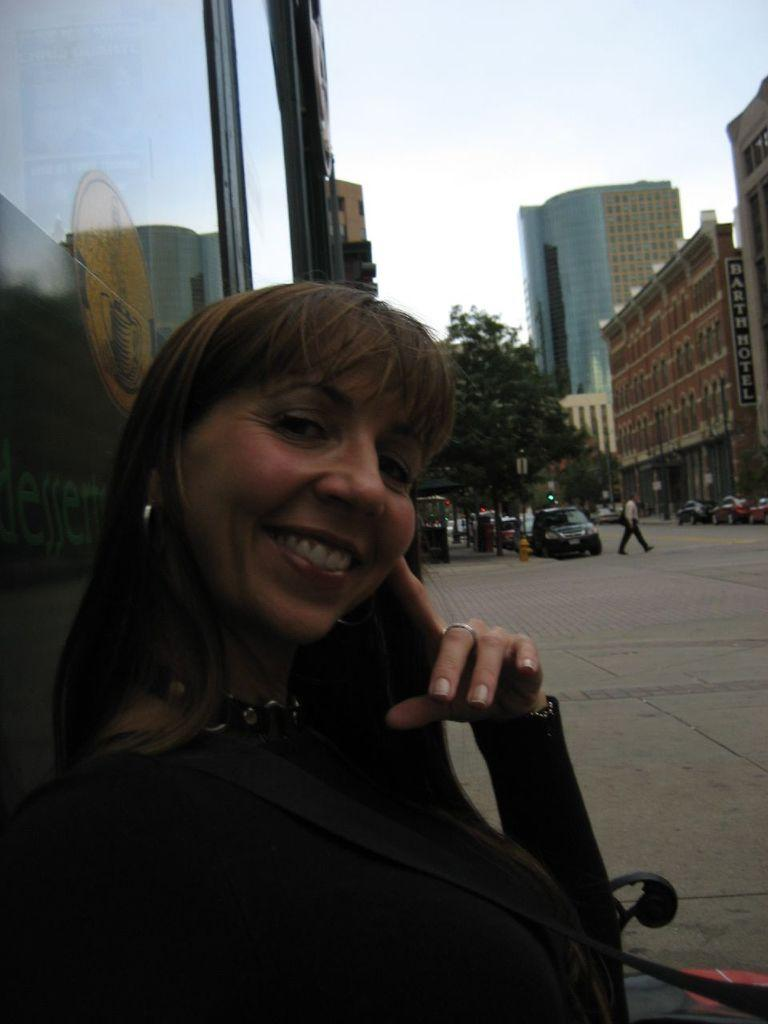What is the main subject in the image? There is a woman standing in the image. What can be seen in the background of the image? There are cars parked on the road, a tree, and buildings visible in the image. What type of nail is being used to burst the tires of the parked cars in the image? There is no nail or bursting of tires present in the image. 